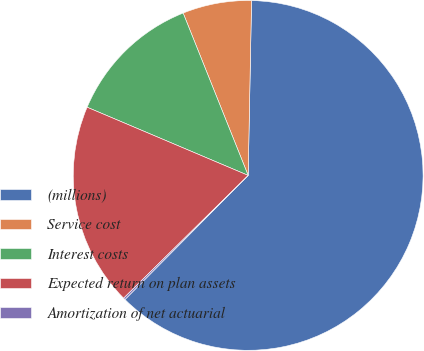Convert chart. <chart><loc_0><loc_0><loc_500><loc_500><pie_chart><fcel>(millions)<fcel>Service cost<fcel>Interest costs<fcel>Expected return on plan assets<fcel>Amortization of net actuarial<nl><fcel>62.13%<fcel>6.37%<fcel>12.56%<fcel>18.76%<fcel>0.17%<nl></chart> 